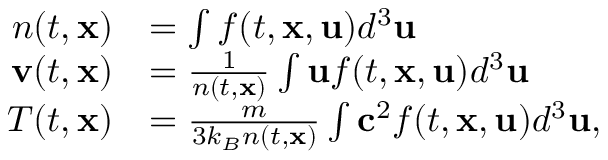<formula> <loc_0><loc_0><loc_500><loc_500>\begin{array} { r l } { n ( t , x ) } & { = \int f ( t , x , u ) d ^ { 3 } u } \\ { v ( t , x ) } & { = \frac { 1 } { n ( t , x ) } \int u f ( t , x , u ) d ^ { 3 } u } \\ { T ( t , x ) } & { = \frac { m } { 3 k _ { B } n ( t , x ) } \int c ^ { 2 } f ( t , x , u ) d ^ { 3 } u , } \end{array}</formula> 